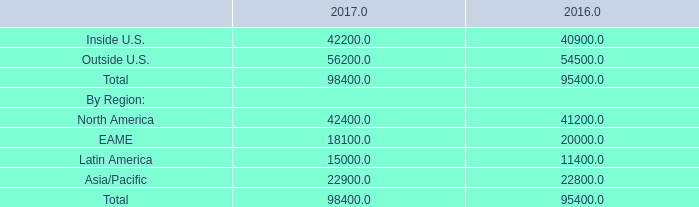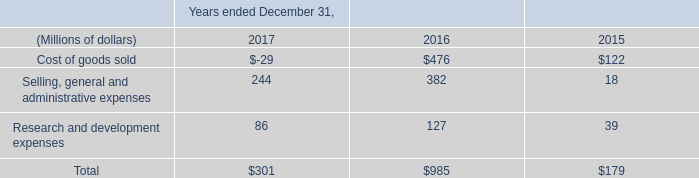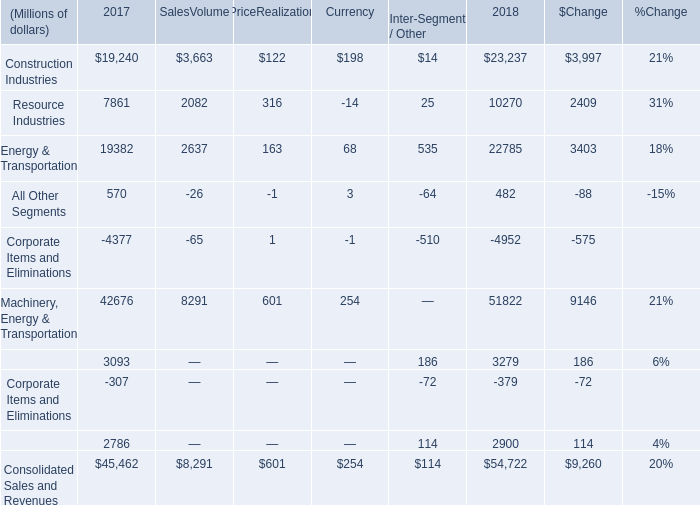What's the sum of all Machinery, Energy & Transportation that are greater than 600 in 2018? (in million) 
Computations: ((42676 + 8291) + 601)
Answer: 51568.0. 